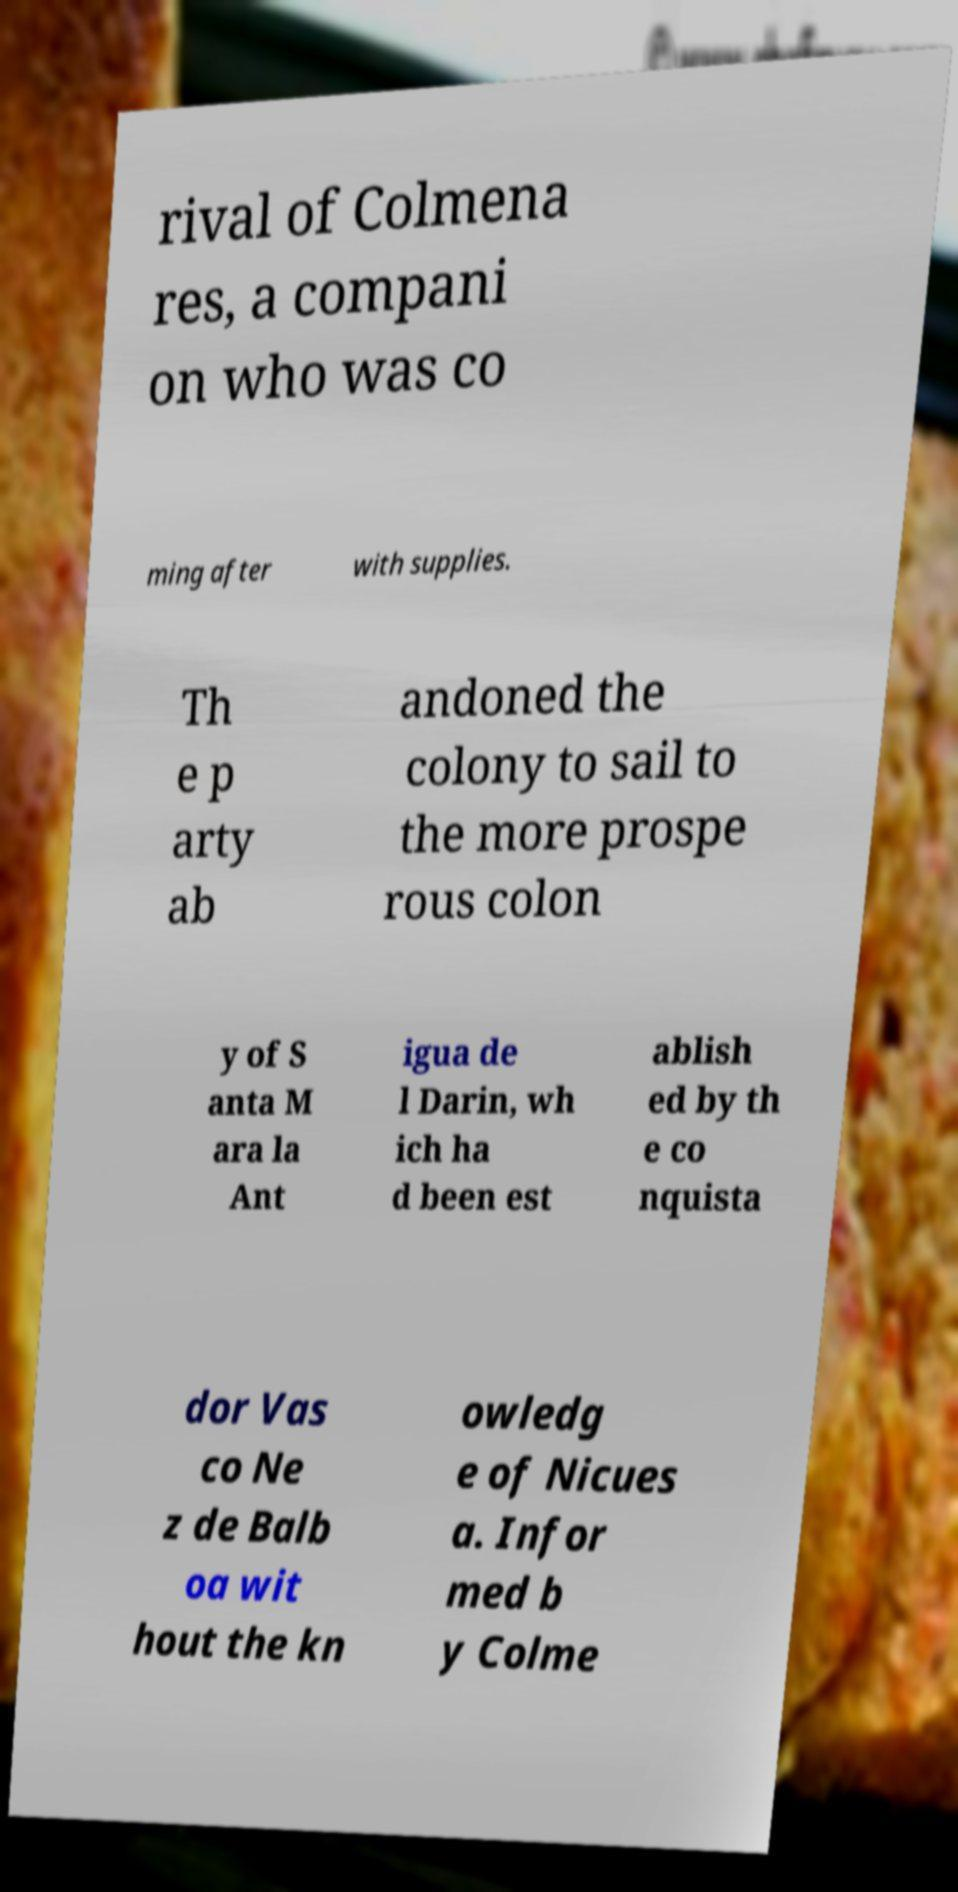Could you extract and type out the text from this image? rival of Colmena res, a compani on who was co ming after with supplies. Th e p arty ab andoned the colony to sail to the more prospe rous colon y of S anta M ara la Ant igua de l Darin, wh ich ha d been est ablish ed by th e co nquista dor Vas co Ne z de Balb oa wit hout the kn owledg e of Nicues a. Infor med b y Colme 